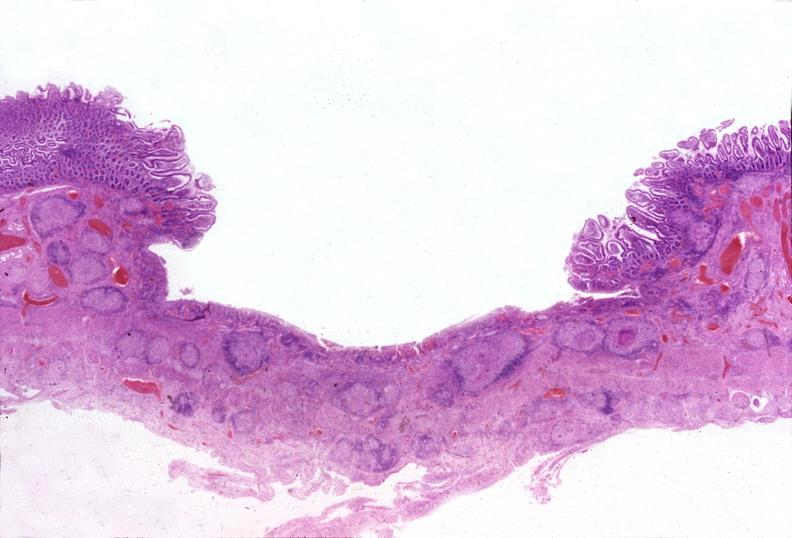does carcinomatosis show small intestine, tuberculous ileitis?
Answer the question using a single word or phrase. No 